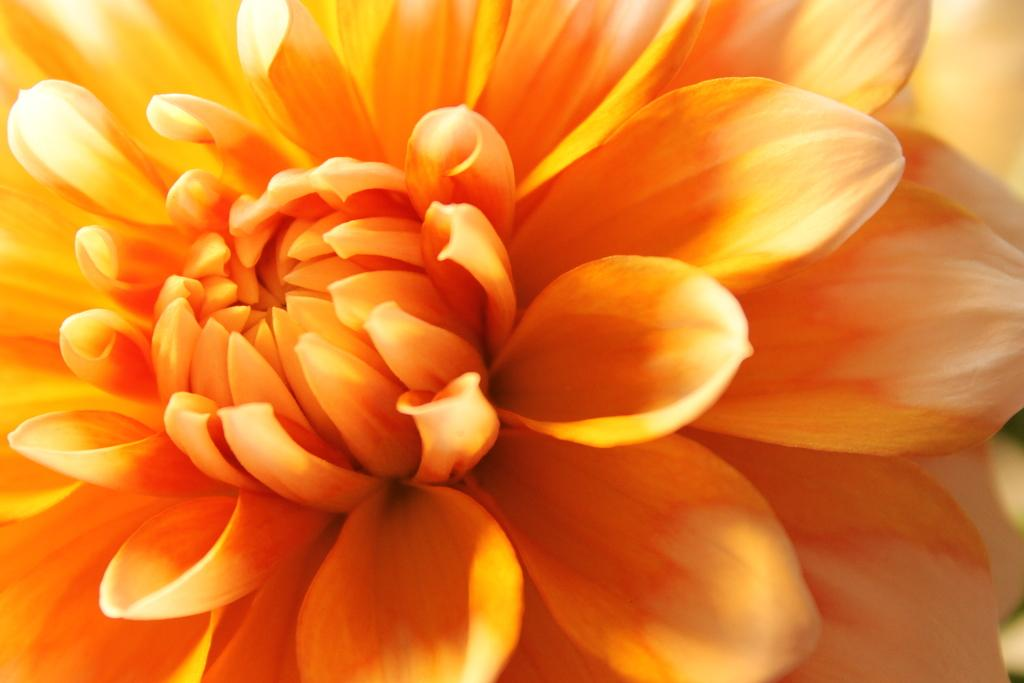What is the main subject of the image? The main subject of the image is a flower. Can you describe the flower in the image? The flower has petals and is in orange color. How many fields can be seen in the image? There are no fields present in the image; it features a single flower. What day of the week is depicted in the image? The image does not depict a specific day of the week; it only shows a flower. 